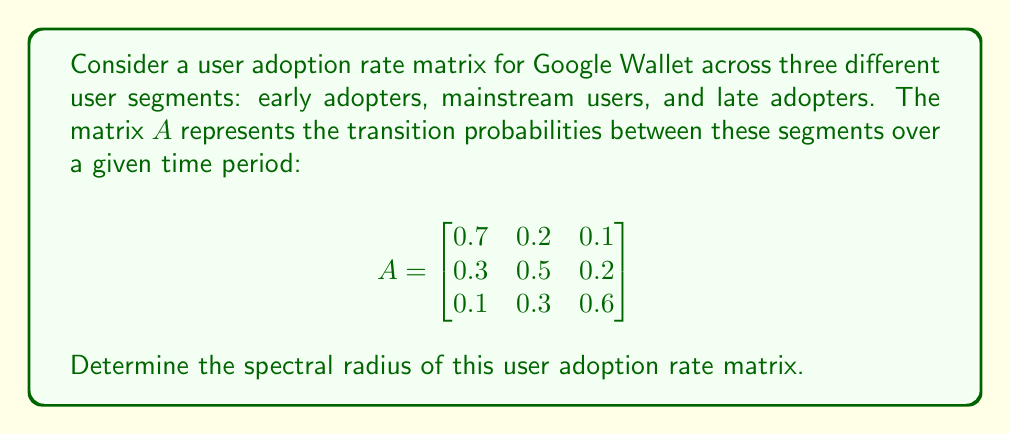Show me your answer to this math problem. To find the spectral radius of matrix $A$, we need to follow these steps:

1) First, calculate the characteristic polynomial of $A$:
   $det(A - \lambda I) = 0$

   $$\begin{vmatrix}
   0.7-\lambda & 0.2 & 0.1 \\
   0.3 & 0.5-\lambda & 0.2 \\
   0.1 & 0.3 & 0.6-\lambda
   \end{vmatrix} = 0$$

2) Expand the determinant:
   $(0.7-\lambda)[(0.5-\lambda)(0.6-\lambda)-0.06] - 0.2[0.3(0.6-\lambda)-0.02] + 0.1[0.3(0.5-\lambda)-0.06] = 0$

3) Simplify:
   $-\lambda^3 + 1.8\lambda^2 - 0.83\lambda + 0.122 = 0$

4) Solve this cubic equation. The roots are the eigenvalues of $A$. Using a numerical method or a computer algebra system, we find the roots:
   $\lambda_1 \approx 1$
   $\lambda_2 \approx 0.5$
   $\lambda_3 \approx 0.3$

5) The spectral radius $\rho(A)$ is the maximum absolute value of the eigenvalues:
   $\rho(A) = \max(|\lambda_1|, |\lambda_2|, |\lambda_3|) = \max(1, 0.5, 0.3) = 1$

Therefore, the spectral radius of the user adoption rate matrix is 1.
Answer: 1 